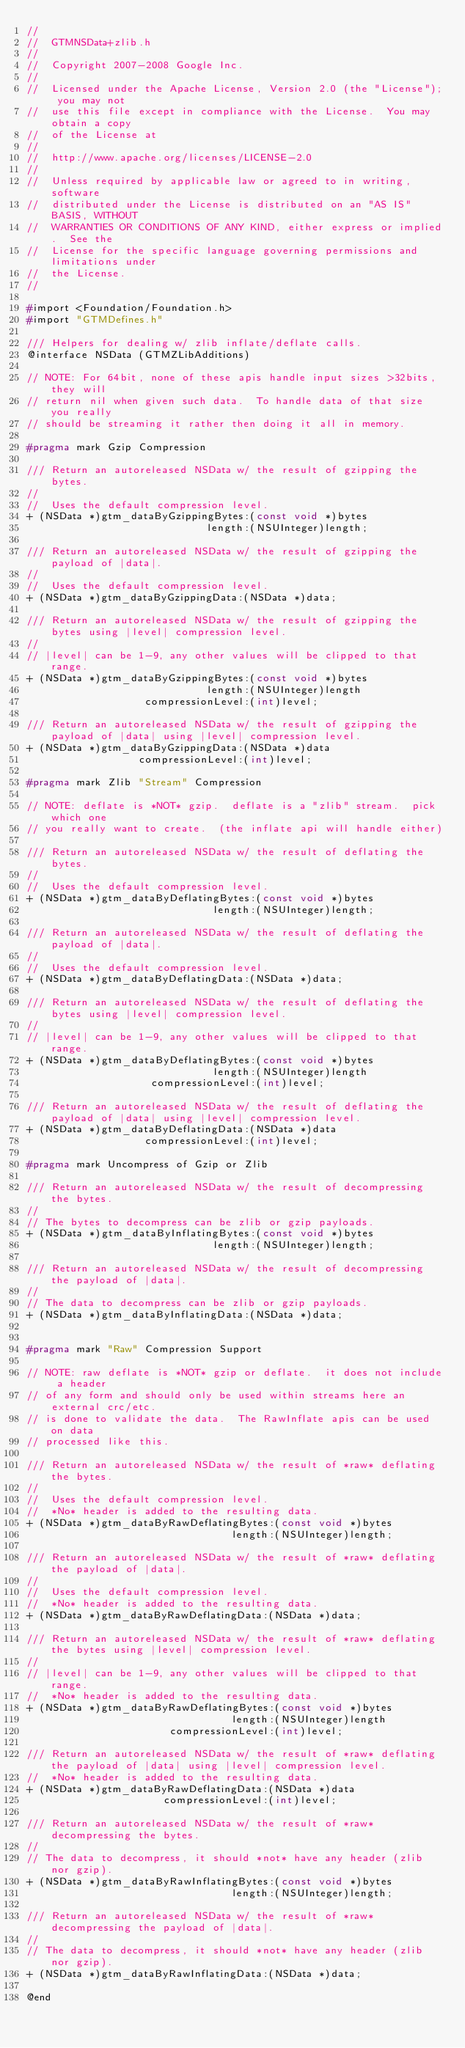Convert code to text. <code><loc_0><loc_0><loc_500><loc_500><_C_>//
//  GTMNSData+zlib.h
//
//  Copyright 2007-2008 Google Inc.
//
//  Licensed under the Apache License, Version 2.0 (the "License"); you may not
//  use this file except in compliance with the License.  You may obtain a copy
//  of the License at
//
//  http://www.apache.org/licenses/LICENSE-2.0
//
//  Unless required by applicable law or agreed to in writing, software
//  distributed under the License is distributed on an "AS IS" BASIS, WITHOUT
//  WARRANTIES OR CONDITIONS OF ANY KIND, either express or implied.  See the
//  License for the specific language governing permissions and limitations under
//  the License.
//

#import <Foundation/Foundation.h>
#import "GTMDefines.h"

/// Helpers for dealing w/ zlib inflate/deflate calls.
@interface NSData (GTMZLibAdditions)

// NOTE: For 64bit, none of these apis handle input sizes >32bits, they will
// return nil when given such data.  To handle data of that size you really
// should be streaming it rather then doing it all in memory.

#pragma mark Gzip Compression

/// Return an autoreleased NSData w/ the result of gzipping the bytes.
//
//  Uses the default compression level.
+ (NSData *)gtm_dataByGzippingBytes:(const void *)bytes
                             length:(NSUInteger)length;

/// Return an autoreleased NSData w/ the result of gzipping the payload of |data|.
//
//  Uses the default compression level.
+ (NSData *)gtm_dataByGzippingData:(NSData *)data;

/// Return an autoreleased NSData w/ the result of gzipping the bytes using |level| compression level.
//
// |level| can be 1-9, any other values will be clipped to that range.
+ (NSData *)gtm_dataByGzippingBytes:(const void *)bytes
                             length:(NSUInteger)length
                   compressionLevel:(int)level;

/// Return an autoreleased NSData w/ the result of gzipping the payload of |data| using |level| compression level.
+ (NSData *)gtm_dataByGzippingData:(NSData *)data
                  compressionLevel:(int)level;

#pragma mark Zlib "Stream" Compression

// NOTE: deflate is *NOT* gzip.  deflate is a "zlib" stream.  pick which one
// you really want to create.  (the inflate api will handle either)

/// Return an autoreleased NSData w/ the result of deflating the bytes.
//
//  Uses the default compression level.
+ (NSData *)gtm_dataByDeflatingBytes:(const void *)bytes
                              length:(NSUInteger)length;

/// Return an autoreleased NSData w/ the result of deflating the payload of |data|.
//
//  Uses the default compression level.
+ (NSData *)gtm_dataByDeflatingData:(NSData *)data;

/// Return an autoreleased NSData w/ the result of deflating the bytes using |level| compression level.
//
// |level| can be 1-9, any other values will be clipped to that range.
+ (NSData *)gtm_dataByDeflatingBytes:(const void *)bytes
                              length:(NSUInteger)length
                    compressionLevel:(int)level;

/// Return an autoreleased NSData w/ the result of deflating the payload of |data| using |level| compression level.
+ (NSData *)gtm_dataByDeflatingData:(NSData *)data
                   compressionLevel:(int)level;

#pragma mark Uncompress of Gzip or Zlib

/// Return an autoreleased NSData w/ the result of decompressing the bytes.
//
// The bytes to decompress can be zlib or gzip payloads.
+ (NSData *)gtm_dataByInflatingBytes:(const void *)bytes
                              length:(NSUInteger)length;

/// Return an autoreleased NSData w/ the result of decompressing the payload of |data|.
//
// The data to decompress can be zlib or gzip payloads.
+ (NSData *)gtm_dataByInflatingData:(NSData *)data;


#pragma mark "Raw" Compression Support

// NOTE: raw deflate is *NOT* gzip or deflate.  it does not include a header
// of any form and should only be used within streams here an external crc/etc.
// is done to validate the data.  The RawInflate apis can be used on data
// processed like this.

/// Return an autoreleased NSData w/ the result of *raw* deflating the bytes.
//
//  Uses the default compression level.
//  *No* header is added to the resulting data.
+ (NSData *)gtm_dataByRawDeflatingBytes:(const void *)bytes
                                 length:(NSUInteger)length;

/// Return an autoreleased NSData w/ the result of *raw* deflating the payload of |data|.
//
//  Uses the default compression level.
//  *No* header is added to the resulting data.
+ (NSData *)gtm_dataByRawDeflatingData:(NSData *)data;

/// Return an autoreleased NSData w/ the result of *raw* deflating the bytes using |level| compression level.
//
// |level| can be 1-9, any other values will be clipped to that range.
//  *No* header is added to the resulting data.
+ (NSData *)gtm_dataByRawDeflatingBytes:(const void *)bytes
                                 length:(NSUInteger)length
                       compressionLevel:(int)level;

/// Return an autoreleased NSData w/ the result of *raw* deflating the payload of |data| using |level| compression level.
//  *No* header is added to the resulting data.
+ (NSData *)gtm_dataByRawDeflatingData:(NSData *)data
                      compressionLevel:(int)level;

/// Return an autoreleased NSData w/ the result of *raw* decompressing the bytes.
//
// The data to decompress, it should *not* have any header (zlib nor gzip).
+ (NSData *)gtm_dataByRawInflatingBytes:(const void *)bytes
                                 length:(NSUInteger)length;

/// Return an autoreleased NSData w/ the result of *raw* decompressing the payload of |data|.
//
// The data to decompress, it should *not* have any header (zlib nor gzip).
+ (NSData *)gtm_dataByRawInflatingData:(NSData *)data;

@end
</code> 